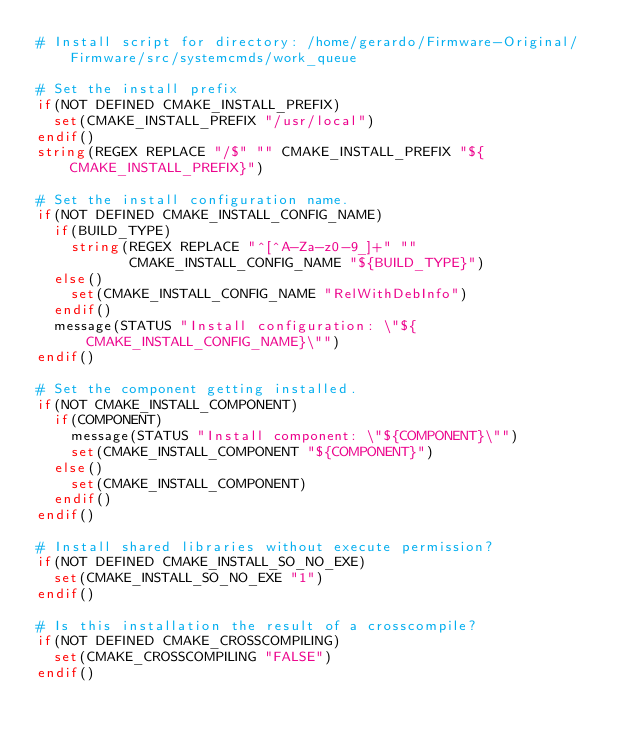<code> <loc_0><loc_0><loc_500><loc_500><_CMake_># Install script for directory: /home/gerardo/Firmware-Original/Firmware/src/systemcmds/work_queue

# Set the install prefix
if(NOT DEFINED CMAKE_INSTALL_PREFIX)
  set(CMAKE_INSTALL_PREFIX "/usr/local")
endif()
string(REGEX REPLACE "/$" "" CMAKE_INSTALL_PREFIX "${CMAKE_INSTALL_PREFIX}")

# Set the install configuration name.
if(NOT DEFINED CMAKE_INSTALL_CONFIG_NAME)
  if(BUILD_TYPE)
    string(REGEX REPLACE "^[^A-Za-z0-9_]+" ""
           CMAKE_INSTALL_CONFIG_NAME "${BUILD_TYPE}")
  else()
    set(CMAKE_INSTALL_CONFIG_NAME "RelWithDebInfo")
  endif()
  message(STATUS "Install configuration: \"${CMAKE_INSTALL_CONFIG_NAME}\"")
endif()

# Set the component getting installed.
if(NOT CMAKE_INSTALL_COMPONENT)
  if(COMPONENT)
    message(STATUS "Install component: \"${COMPONENT}\"")
    set(CMAKE_INSTALL_COMPONENT "${COMPONENT}")
  else()
    set(CMAKE_INSTALL_COMPONENT)
  endif()
endif()

# Install shared libraries without execute permission?
if(NOT DEFINED CMAKE_INSTALL_SO_NO_EXE)
  set(CMAKE_INSTALL_SO_NO_EXE "1")
endif()

# Is this installation the result of a crosscompile?
if(NOT DEFINED CMAKE_CROSSCOMPILING)
  set(CMAKE_CROSSCOMPILING "FALSE")
endif()

</code> 